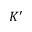Convert formula to latex. <formula><loc_0><loc_0><loc_500><loc_500>K ^ { \prime }</formula> 